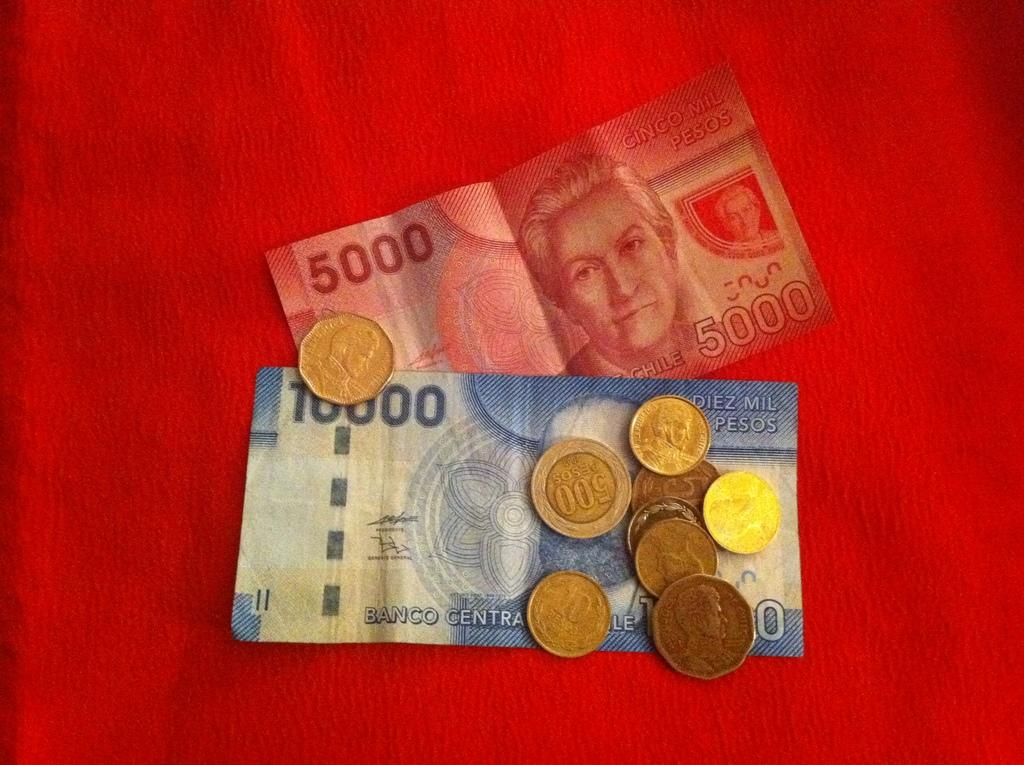What type of currency notes are present in the image? There is a five thousand currency note and a ten thousand currency note in the image. Are there any other forms of currency visible in the image? Yes, currency coins are visible in the image. What is the color of the background in the image? The background of the image is red in color. What type of corn is being stored in the can in the image? There is no corn or can present in the image; it only features currency notes and coins. 